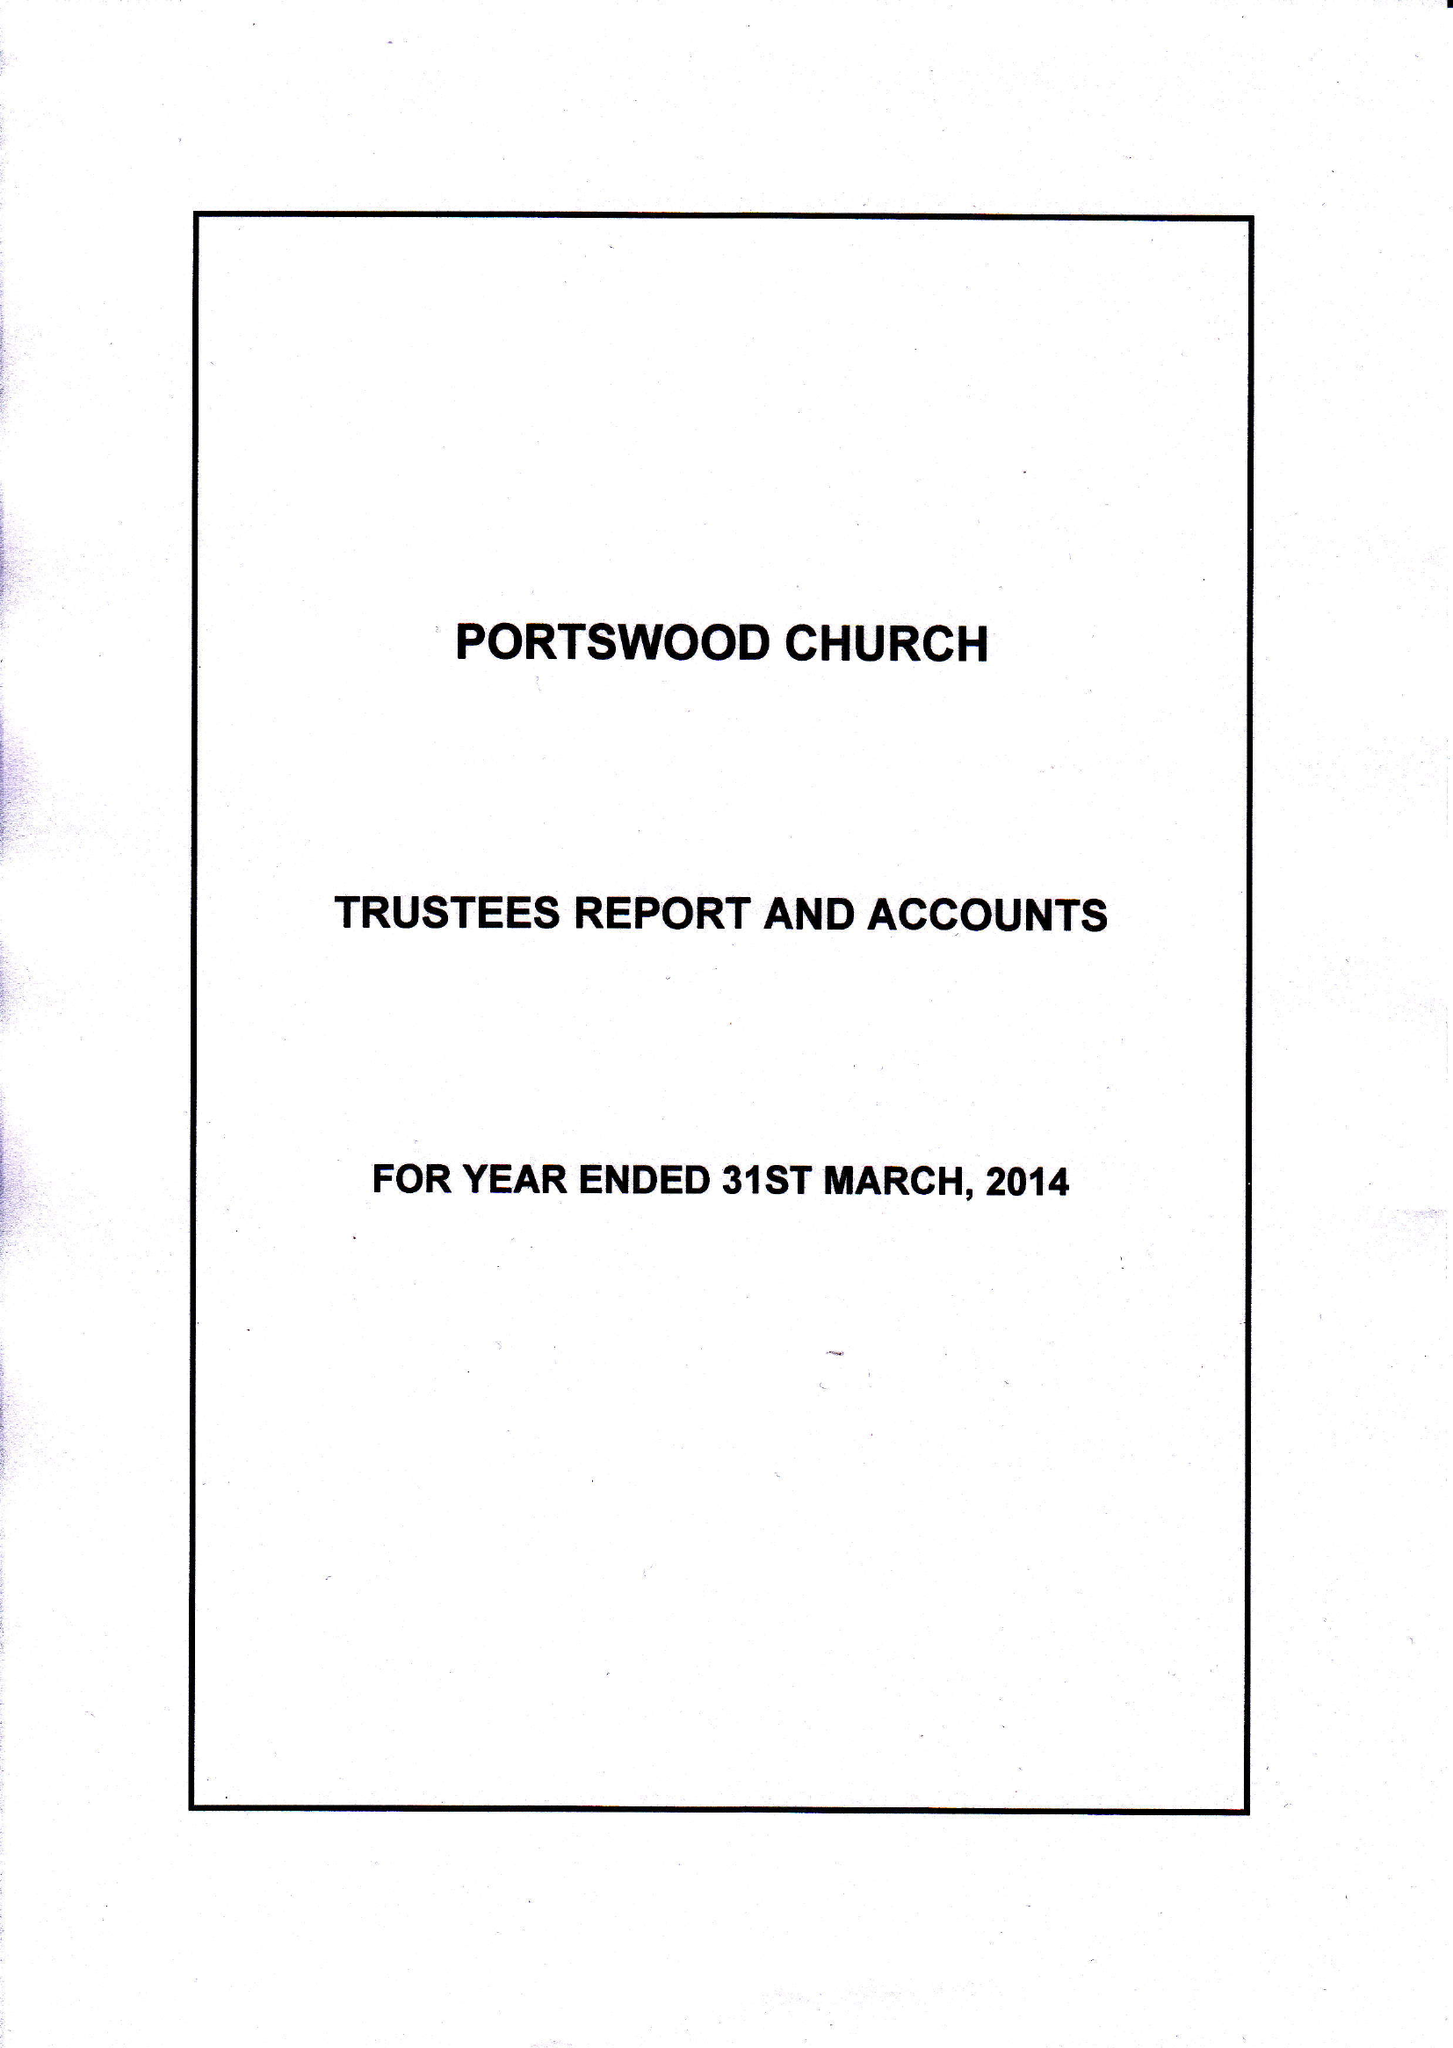What is the value for the income_annually_in_british_pounds?
Answer the question using a single word or phrase. 277114.00 